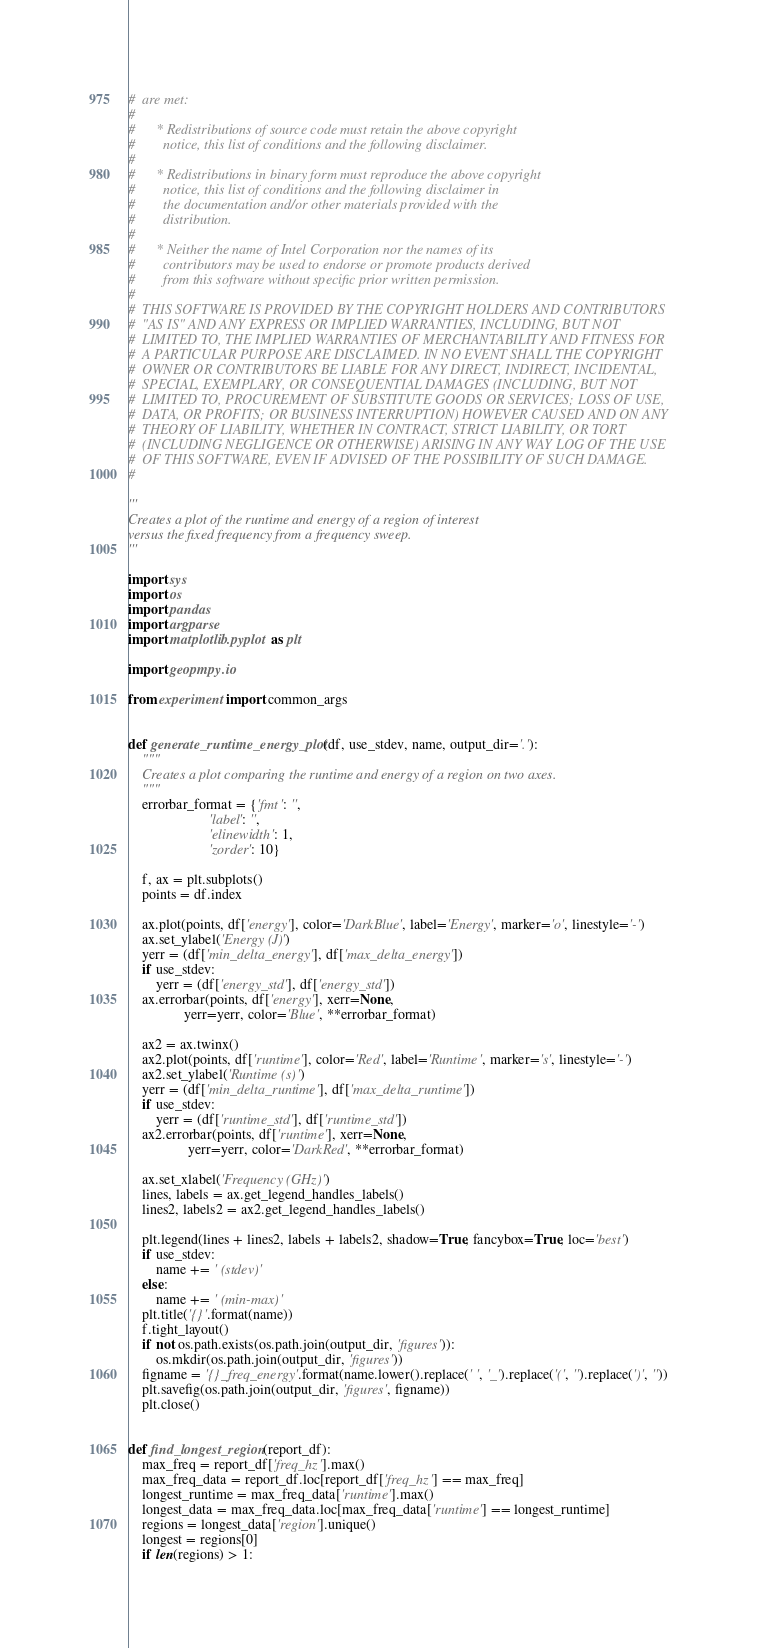<code> <loc_0><loc_0><loc_500><loc_500><_Python_>#  are met:
#
#      * Redistributions of source code must retain the above copyright
#        notice, this list of conditions and the following disclaimer.
#
#      * Redistributions in binary form must reproduce the above copyright
#        notice, this list of conditions and the following disclaimer in
#        the documentation and/or other materials provided with the
#        distribution.
#
#      * Neither the name of Intel Corporation nor the names of its
#        contributors may be used to endorse or promote products derived
#        from this software without specific prior written permission.
#
#  THIS SOFTWARE IS PROVIDED BY THE COPYRIGHT HOLDERS AND CONTRIBUTORS
#  "AS IS" AND ANY EXPRESS OR IMPLIED WARRANTIES, INCLUDING, BUT NOT
#  LIMITED TO, THE IMPLIED WARRANTIES OF MERCHANTABILITY AND FITNESS FOR
#  A PARTICULAR PURPOSE ARE DISCLAIMED. IN NO EVENT SHALL THE COPYRIGHT
#  OWNER OR CONTRIBUTORS BE LIABLE FOR ANY DIRECT, INDIRECT, INCIDENTAL,
#  SPECIAL, EXEMPLARY, OR CONSEQUENTIAL DAMAGES (INCLUDING, BUT NOT
#  LIMITED TO, PROCUREMENT OF SUBSTITUTE GOODS OR SERVICES; LOSS OF USE,
#  DATA, OR PROFITS; OR BUSINESS INTERRUPTION) HOWEVER CAUSED AND ON ANY
#  THEORY OF LIABILITY, WHETHER IN CONTRACT, STRICT LIABILITY, OR TORT
#  (INCLUDING NEGLIGENCE OR OTHERWISE) ARISING IN ANY WAY LOG OF THE USE
#  OF THIS SOFTWARE, EVEN IF ADVISED OF THE POSSIBILITY OF SUCH DAMAGE.
#

'''
Creates a plot of the runtime and energy of a region of interest
versus the fixed frequency from a frequency sweep.
'''

import sys
import os
import pandas
import argparse
import matplotlib.pyplot as plt

import geopmpy.io

from experiment import common_args


def generate_runtime_energy_plot(df, use_stdev, name, output_dir='.'):
    """
    Creates a plot comparing the runtime and energy of a region on two axes.
    """
    errorbar_format = {'fmt': '',
                       'label': '',
                       'elinewidth': 1,
                       'zorder': 10}

    f, ax = plt.subplots()
    points = df.index

    ax.plot(points, df['energy'], color='DarkBlue', label='Energy', marker='o', linestyle='-')
    ax.set_ylabel('Energy (J)')
    yerr = (df['min_delta_energy'], df['max_delta_energy'])
    if use_stdev:
        yerr = (df['energy_std'], df['energy_std'])
    ax.errorbar(points, df['energy'], xerr=None,
                yerr=yerr, color='Blue', **errorbar_format)

    ax2 = ax.twinx()
    ax2.plot(points, df['runtime'], color='Red', label='Runtime', marker='s', linestyle='-')
    ax2.set_ylabel('Runtime (s)')
    yerr = (df['min_delta_runtime'], df['max_delta_runtime'])
    if use_stdev:
        yerr = (df['runtime_std'], df['runtime_std'])
    ax2.errorbar(points, df['runtime'], xerr=None,
                 yerr=yerr, color='DarkRed', **errorbar_format)

    ax.set_xlabel('Frequency (GHz)')
    lines, labels = ax.get_legend_handles_labels()
    lines2, labels2 = ax2.get_legend_handles_labels()

    plt.legend(lines + lines2, labels + labels2, shadow=True, fancybox=True, loc='best')
    if use_stdev:
        name += ' (stdev)'
    else:
        name += ' (min-max)'
    plt.title('{}'.format(name))
    f.tight_layout()
    if not os.path.exists(os.path.join(output_dir, 'figures')):
        os.mkdir(os.path.join(output_dir, 'figures'))
    figname = '{}_freq_energy'.format(name.lower().replace(' ', '_').replace('(', '').replace(')', ''))
    plt.savefig(os.path.join(output_dir, 'figures', figname))
    plt.close()


def find_longest_region(report_df):
    max_freq = report_df['freq_hz'].max()
    max_freq_data = report_df.loc[report_df['freq_hz'] == max_freq]
    longest_runtime = max_freq_data['runtime'].max()
    longest_data = max_freq_data.loc[max_freq_data['runtime'] == longest_runtime]
    regions = longest_data['region'].unique()
    longest = regions[0]
    if len(regions) > 1:</code> 